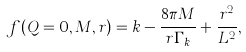<formula> <loc_0><loc_0><loc_500><loc_500>f ( Q = 0 , M , r ) = k - \frac { 8 \pi M } { r \Gamma _ { k } } + \frac { r ^ { 2 } } { L ^ { 2 } } ,</formula> 